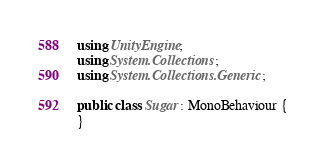<code> <loc_0><loc_0><loc_500><loc_500><_C#_>using UnityEngine;
using System.Collections;
using System.Collections.Generic;

public class Sugar : MonoBehaviour {
}
</code> 